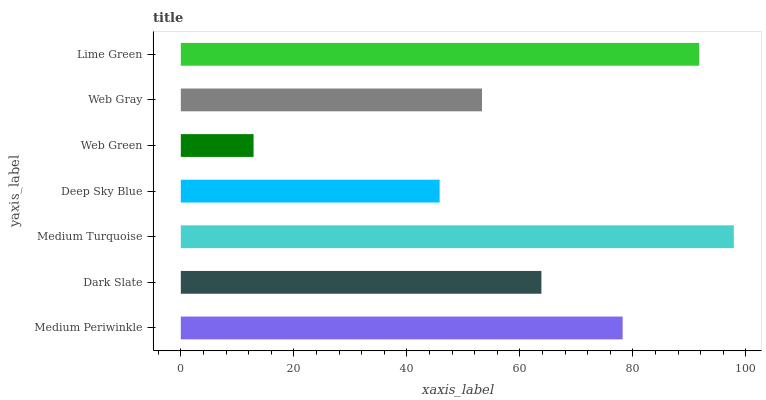Is Web Green the minimum?
Answer yes or no. Yes. Is Medium Turquoise the maximum?
Answer yes or no. Yes. Is Dark Slate the minimum?
Answer yes or no. No. Is Dark Slate the maximum?
Answer yes or no. No. Is Medium Periwinkle greater than Dark Slate?
Answer yes or no. Yes. Is Dark Slate less than Medium Periwinkle?
Answer yes or no. Yes. Is Dark Slate greater than Medium Periwinkle?
Answer yes or no. No. Is Medium Periwinkle less than Dark Slate?
Answer yes or no. No. Is Dark Slate the high median?
Answer yes or no. Yes. Is Dark Slate the low median?
Answer yes or no. Yes. Is Deep Sky Blue the high median?
Answer yes or no. No. Is Lime Green the low median?
Answer yes or no. No. 